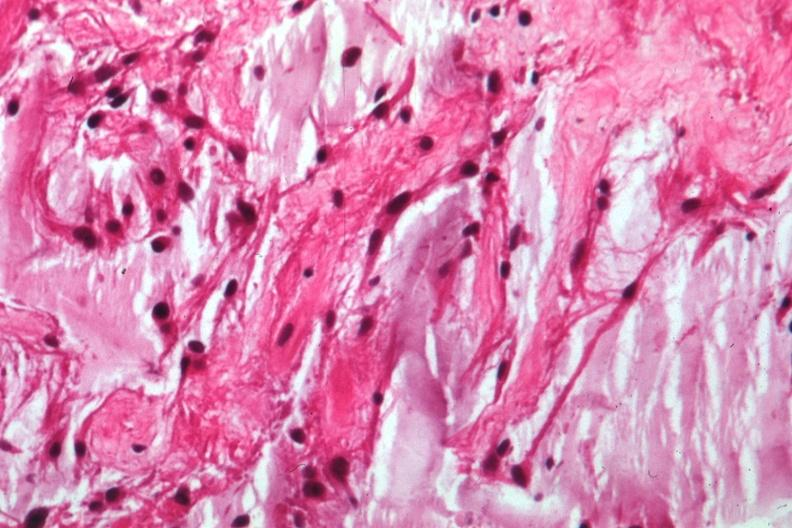s eye present?
Answer the question using a single word or phrase. Yes 